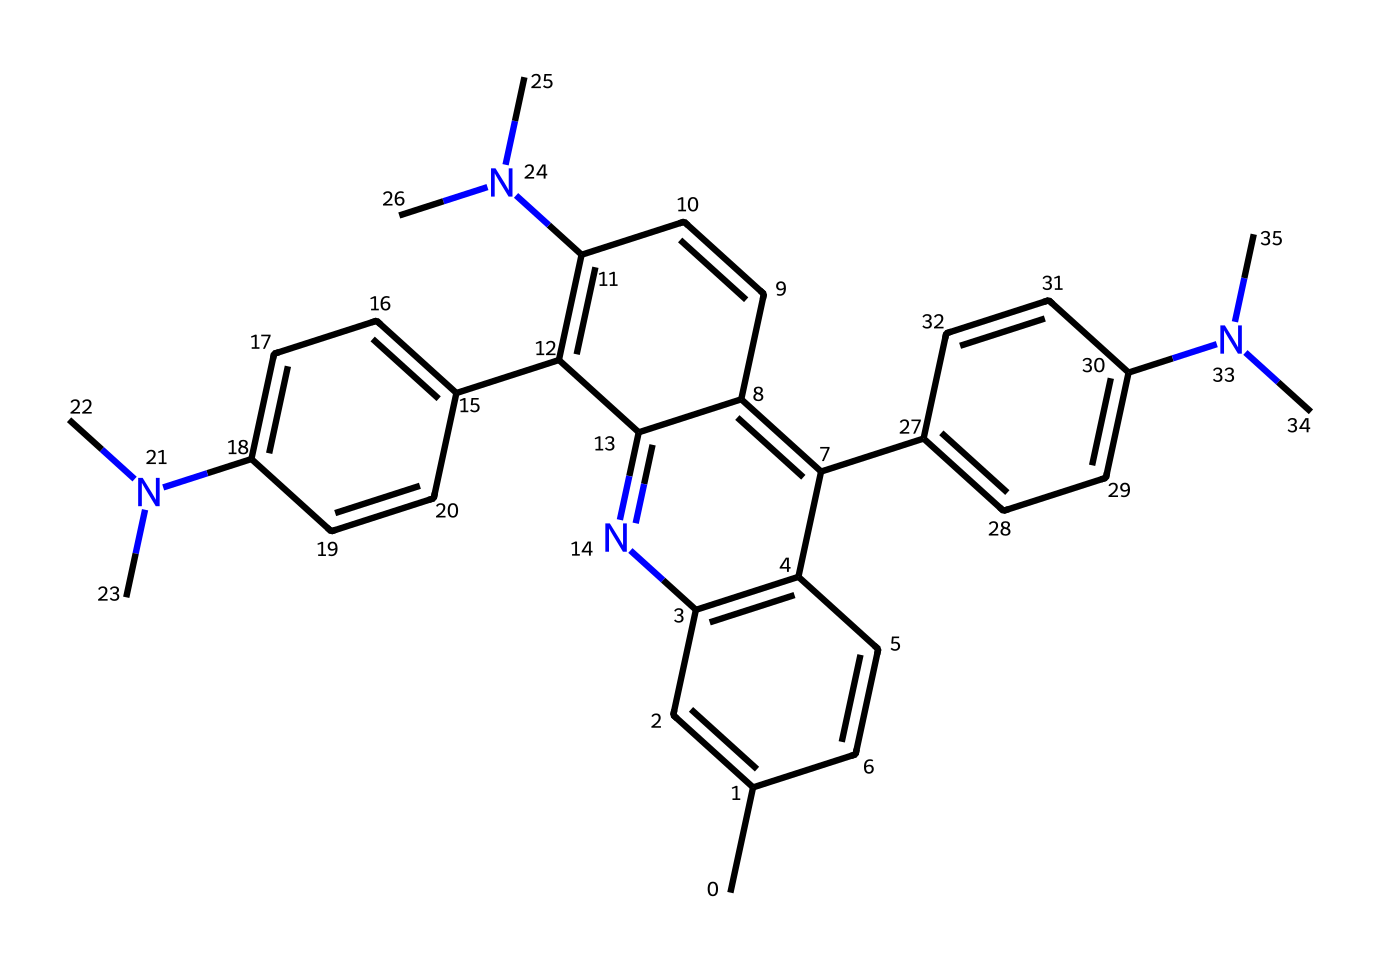How many nitrogen atoms are present in this structure? By analyzing the provided SMILES, we can identify the presence of nitrogen atoms represented by "N". Counting these in the chemical structure, there are four distinct nitrogen atoms present.
Answer: four What is the primary functional group present in this dye? The dye’s structure shows multiple nitrogen atoms, which are characteristic of amines and probably imines. However, the prominent features are those containing the nitrogen linked to aromatic systems indicating it falls under the category of azo or aromatic amine, suggesting the presence of a nitrogen-containing aromatic structure.
Answer: amine How many rings are present in this chemical structure? By visual inspection of the SMILES representation, the structure has multiple cyclic components, and counting the distinct ring closures represented in the SMILES leads to identifying that there are five rings in total.
Answer: five Which type of molecular interaction would contribute most to the dye's thermochromic properties? The presence of nitrogen atoms implies the likelihood of hydrogen bonding and charge-transfer interactions. These interactions could facilitate the color-change mechanism in response to temperature changes, making such interactions pivotal for thermochromism.
Answer: hydrogen bonding What makes this compound suitable for temperature-sensitive cookware? The presence of thermochromic properties is primarily due to the electronic rearrangements around the multiple nitrogen-containing aromatic rings, causing the dye to change color with temperature, which is crucial for indicating heat levels in cookware.
Answer: thermochromic properties What role does the aromatic structure play in this dye? The aromatic rings contribute to the stability of the dye through resonance, allowing for more extensive electronic delocalization. This stability is key in ensuring the dye remains functional under varying temperatures, which is essential for cookware applications.
Answer: stability through resonance 